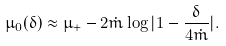<formula> <loc_0><loc_0><loc_500><loc_500>\mu _ { 0 } ( \delta ) \approx \mu _ { + } - 2 \dot { m } \log | 1 - \frac { \delta } { 4 \dot { m } } | .</formula> 